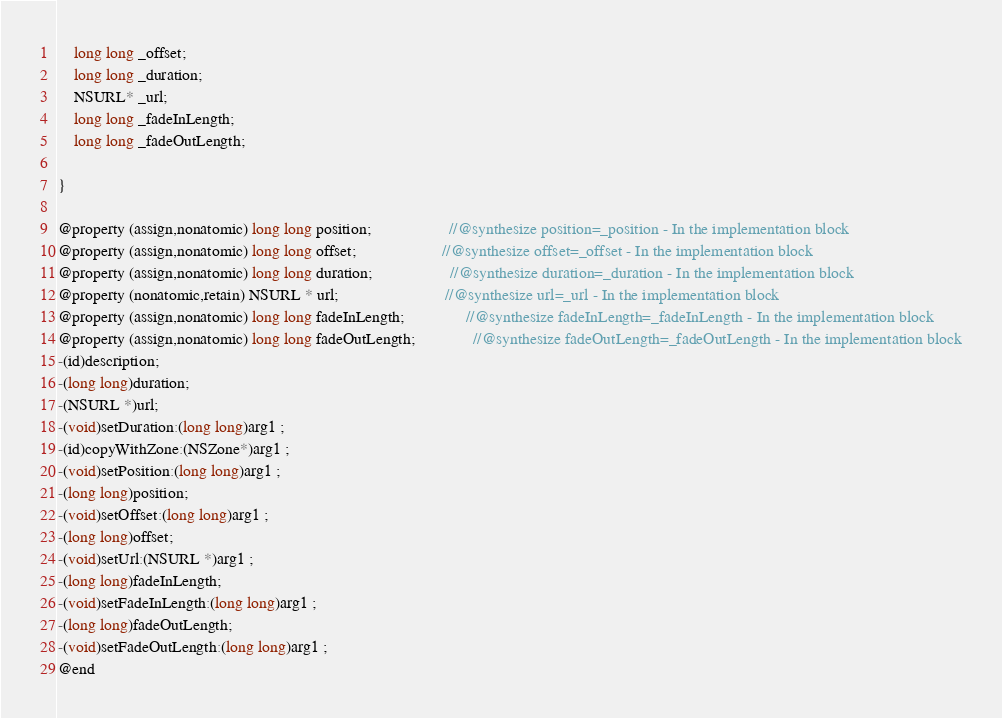Convert code to text. <code><loc_0><loc_0><loc_500><loc_500><_C_>	long long _offset;
	long long _duration;
	NSURL* _url;
	long long _fadeInLength;
	long long _fadeOutLength;

}

@property (assign,nonatomic) long long position;                   //@synthesize position=_position - In the implementation block
@property (assign,nonatomic) long long offset;                     //@synthesize offset=_offset - In the implementation block
@property (assign,nonatomic) long long duration;                   //@synthesize duration=_duration - In the implementation block
@property (nonatomic,retain) NSURL * url;                          //@synthesize url=_url - In the implementation block
@property (assign,nonatomic) long long fadeInLength;               //@synthesize fadeInLength=_fadeInLength - In the implementation block
@property (assign,nonatomic) long long fadeOutLength;              //@synthesize fadeOutLength=_fadeOutLength - In the implementation block
-(id)description;
-(long long)duration;
-(NSURL *)url;
-(void)setDuration:(long long)arg1 ;
-(id)copyWithZone:(NSZone*)arg1 ;
-(void)setPosition:(long long)arg1 ;
-(long long)position;
-(void)setOffset:(long long)arg1 ;
-(long long)offset;
-(void)setUrl:(NSURL *)arg1 ;
-(long long)fadeInLength;
-(void)setFadeInLength:(long long)arg1 ;
-(long long)fadeOutLength;
-(void)setFadeOutLength:(long long)arg1 ;
@end

</code> 